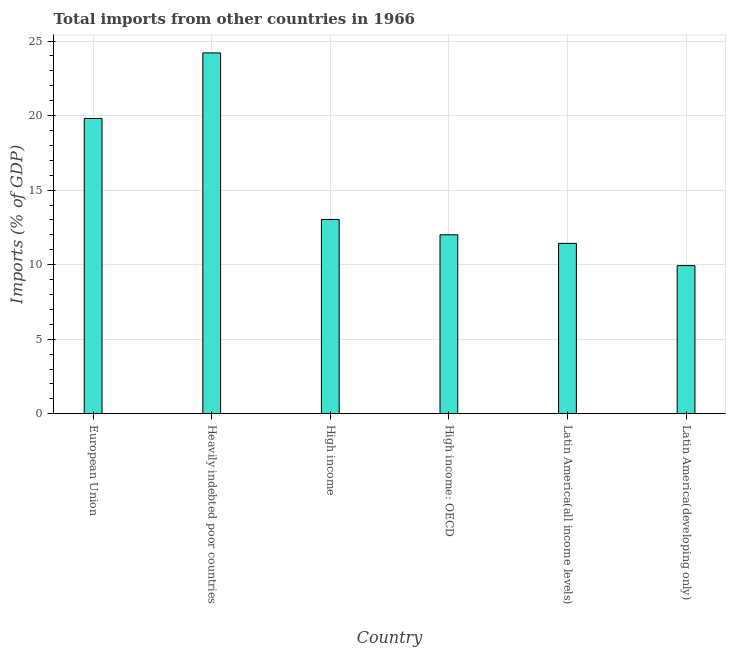Does the graph contain any zero values?
Offer a very short reply. No. Does the graph contain grids?
Ensure brevity in your answer.  Yes. What is the title of the graph?
Give a very brief answer. Total imports from other countries in 1966. What is the label or title of the Y-axis?
Your response must be concise. Imports (% of GDP). What is the total imports in Latin America(developing only)?
Your answer should be compact. 9.94. Across all countries, what is the maximum total imports?
Your answer should be compact. 24.21. Across all countries, what is the minimum total imports?
Give a very brief answer. 9.94. In which country was the total imports maximum?
Provide a succinct answer. Heavily indebted poor countries. In which country was the total imports minimum?
Your answer should be compact. Latin America(developing only). What is the sum of the total imports?
Your answer should be compact. 90.42. What is the difference between the total imports in European Union and Latin America(developing only)?
Give a very brief answer. 9.87. What is the average total imports per country?
Offer a very short reply. 15.07. What is the median total imports?
Offer a terse response. 12.52. What is the ratio of the total imports in High income to that in High income: OECD?
Your answer should be compact. 1.09. Is the difference between the total imports in Heavily indebted poor countries and Latin America(developing only) greater than the difference between any two countries?
Your response must be concise. Yes. What is the difference between the highest and the second highest total imports?
Keep it short and to the point. 4.4. Is the sum of the total imports in High income: OECD and Latin America(all income levels) greater than the maximum total imports across all countries?
Make the answer very short. No. What is the difference between the highest and the lowest total imports?
Offer a terse response. 14.27. How many bars are there?
Make the answer very short. 6. What is the difference between two consecutive major ticks on the Y-axis?
Offer a terse response. 5. What is the Imports (% of GDP) of European Union?
Give a very brief answer. 19.81. What is the Imports (% of GDP) of Heavily indebted poor countries?
Provide a short and direct response. 24.21. What is the Imports (% of GDP) of High income?
Your answer should be very brief. 13.03. What is the Imports (% of GDP) in High income: OECD?
Your answer should be very brief. 12. What is the Imports (% of GDP) in Latin America(all income levels)?
Your response must be concise. 11.43. What is the Imports (% of GDP) in Latin America(developing only)?
Provide a succinct answer. 9.94. What is the difference between the Imports (% of GDP) in European Union and Heavily indebted poor countries?
Your answer should be compact. -4.4. What is the difference between the Imports (% of GDP) in European Union and High income?
Make the answer very short. 6.78. What is the difference between the Imports (% of GDP) in European Union and High income: OECD?
Your answer should be very brief. 7.81. What is the difference between the Imports (% of GDP) in European Union and Latin America(all income levels)?
Provide a short and direct response. 8.38. What is the difference between the Imports (% of GDP) in European Union and Latin America(developing only)?
Provide a short and direct response. 9.87. What is the difference between the Imports (% of GDP) in Heavily indebted poor countries and High income?
Your answer should be very brief. 11.17. What is the difference between the Imports (% of GDP) in Heavily indebted poor countries and High income: OECD?
Provide a succinct answer. 12.2. What is the difference between the Imports (% of GDP) in Heavily indebted poor countries and Latin America(all income levels)?
Your response must be concise. 12.78. What is the difference between the Imports (% of GDP) in Heavily indebted poor countries and Latin America(developing only)?
Offer a very short reply. 14.27. What is the difference between the Imports (% of GDP) in High income and High income: OECD?
Your answer should be compact. 1.03. What is the difference between the Imports (% of GDP) in High income and Latin America(all income levels)?
Give a very brief answer. 1.6. What is the difference between the Imports (% of GDP) in High income and Latin America(developing only)?
Offer a very short reply. 3.1. What is the difference between the Imports (% of GDP) in High income: OECD and Latin America(all income levels)?
Give a very brief answer. 0.57. What is the difference between the Imports (% of GDP) in High income: OECD and Latin America(developing only)?
Offer a terse response. 2.07. What is the difference between the Imports (% of GDP) in Latin America(all income levels) and Latin America(developing only)?
Provide a short and direct response. 1.49. What is the ratio of the Imports (% of GDP) in European Union to that in Heavily indebted poor countries?
Make the answer very short. 0.82. What is the ratio of the Imports (% of GDP) in European Union to that in High income?
Offer a terse response. 1.52. What is the ratio of the Imports (% of GDP) in European Union to that in High income: OECD?
Ensure brevity in your answer.  1.65. What is the ratio of the Imports (% of GDP) in European Union to that in Latin America(all income levels)?
Give a very brief answer. 1.73. What is the ratio of the Imports (% of GDP) in European Union to that in Latin America(developing only)?
Keep it short and to the point. 1.99. What is the ratio of the Imports (% of GDP) in Heavily indebted poor countries to that in High income?
Ensure brevity in your answer.  1.86. What is the ratio of the Imports (% of GDP) in Heavily indebted poor countries to that in High income: OECD?
Your answer should be compact. 2.02. What is the ratio of the Imports (% of GDP) in Heavily indebted poor countries to that in Latin America(all income levels)?
Make the answer very short. 2.12. What is the ratio of the Imports (% of GDP) in Heavily indebted poor countries to that in Latin America(developing only)?
Give a very brief answer. 2.44. What is the ratio of the Imports (% of GDP) in High income to that in High income: OECD?
Keep it short and to the point. 1.09. What is the ratio of the Imports (% of GDP) in High income to that in Latin America(all income levels)?
Your answer should be very brief. 1.14. What is the ratio of the Imports (% of GDP) in High income to that in Latin America(developing only)?
Your answer should be compact. 1.31. What is the ratio of the Imports (% of GDP) in High income: OECD to that in Latin America(all income levels)?
Provide a succinct answer. 1.05. What is the ratio of the Imports (% of GDP) in High income: OECD to that in Latin America(developing only)?
Provide a succinct answer. 1.21. What is the ratio of the Imports (% of GDP) in Latin America(all income levels) to that in Latin America(developing only)?
Offer a very short reply. 1.15. 